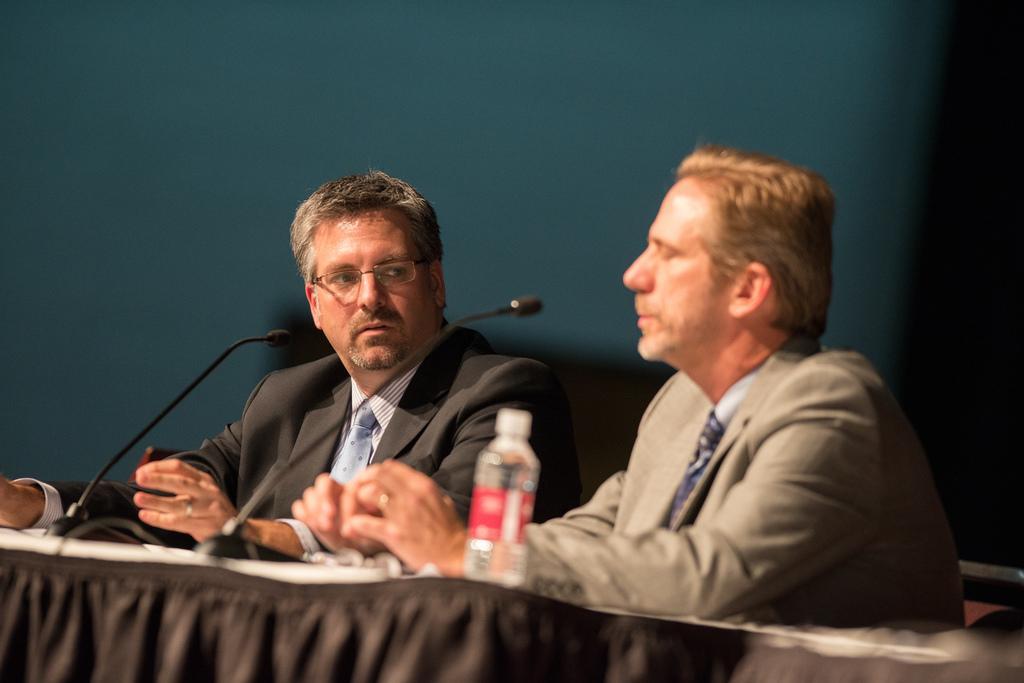In one or two sentences, can you explain what this image depicts? In this image I can see two persons sitting. In front I can see mics,bottle on the table. Background is in green and black color. 